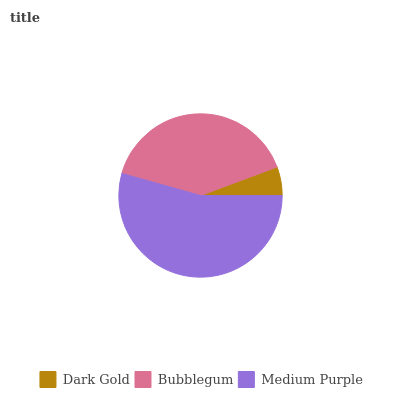Is Dark Gold the minimum?
Answer yes or no. Yes. Is Medium Purple the maximum?
Answer yes or no. Yes. Is Bubblegum the minimum?
Answer yes or no. No. Is Bubblegum the maximum?
Answer yes or no. No. Is Bubblegum greater than Dark Gold?
Answer yes or no. Yes. Is Dark Gold less than Bubblegum?
Answer yes or no. Yes. Is Dark Gold greater than Bubblegum?
Answer yes or no. No. Is Bubblegum less than Dark Gold?
Answer yes or no. No. Is Bubblegum the high median?
Answer yes or no. Yes. Is Bubblegum the low median?
Answer yes or no. Yes. Is Dark Gold the high median?
Answer yes or no. No. Is Dark Gold the low median?
Answer yes or no. No. 